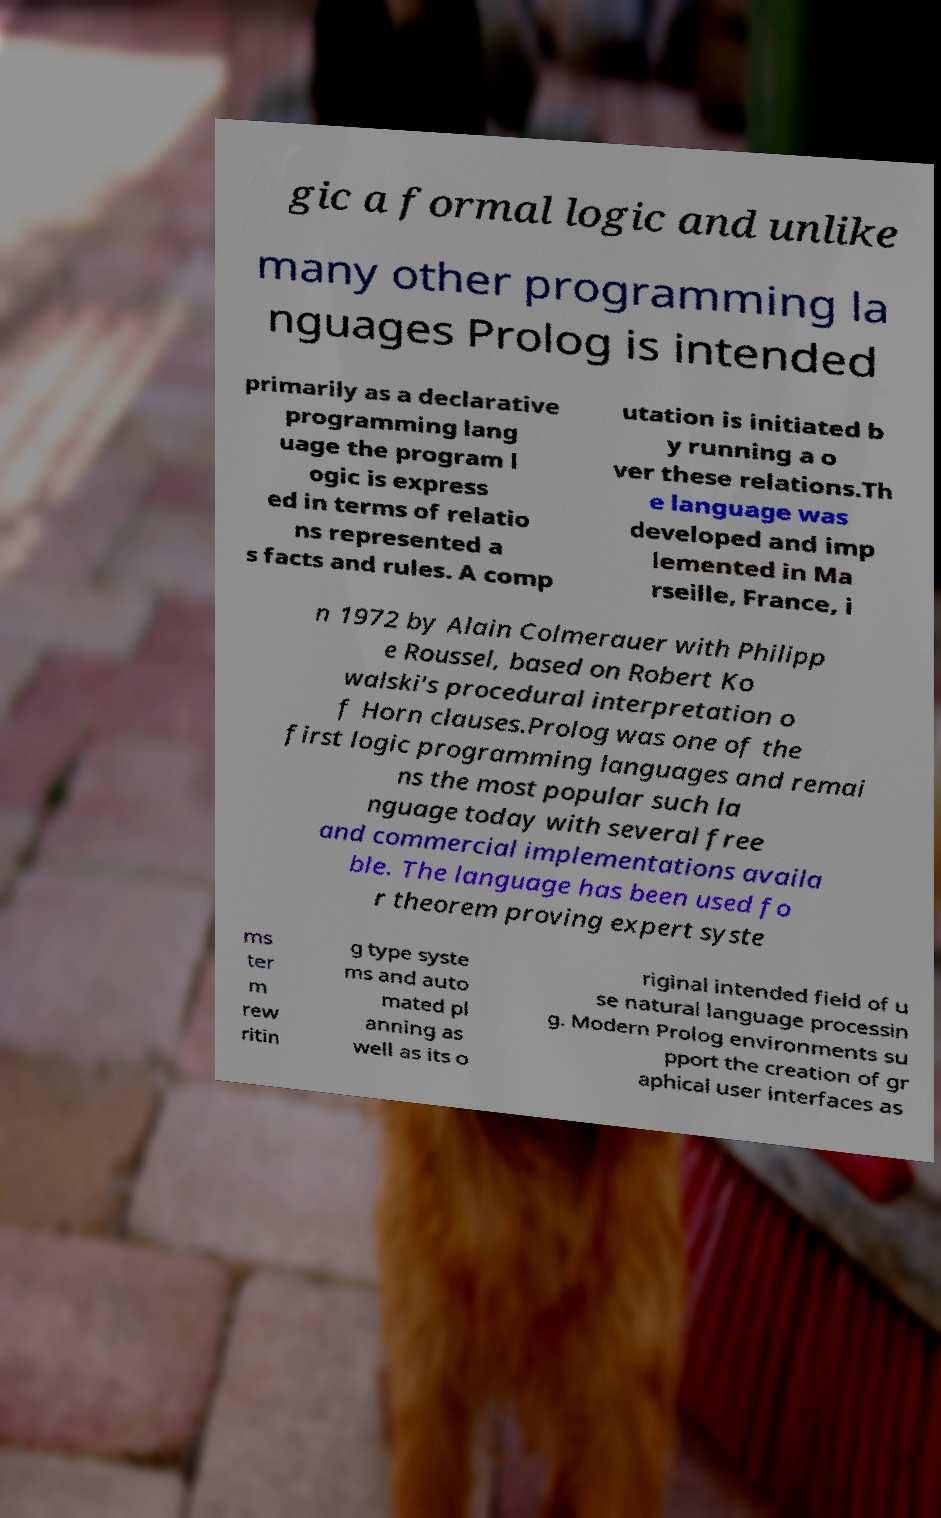Could you extract and type out the text from this image? gic a formal logic and unlike many other programming la nguages Prolog is intended primarily as a declarative programming lang uage the program l ogic is express ed in terms of relatio ns represented a s facts and rules. A comp utation is initiated b y running a o ver these relations.Th e language was developed and imp lemented in Ma rseille, France, i n 1972 by Alain Colmerauer with Philipp e Roussel, based on Robert Ko walski's procedural interpretation o f Horn clauses.Prolog was one of the first logic programming languages and remai ns the most popular such la nguage today with several free and commercial implementations availa ble. The language has been used fo r theorem proving expert syste ms ter m rew ritin g type syste ms and auto mated pl anning as well as its o riginal intended field of u se natural language processin g. Modern Prolog environments su pport the creation of gr aphical user interfaces as 